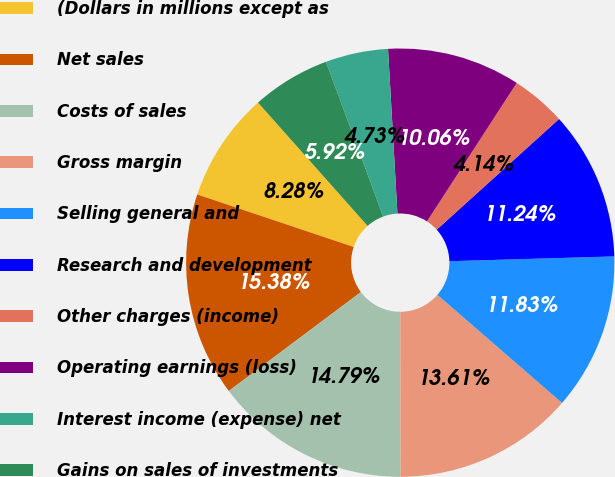Convert chart to OTSL. <chart><loc_0><loc_0><loc_500><loc_500><pie_chart><fcel>(Dollars in millions except as<fcel>Net sales<fcel>Costs of sales<fcel>Gross margin<fcel>Selling general and<fcel>Research and development<fcel>Other charges (income)<fcel>Operating earnings (loss)<fcel>Interest income (expense) net<fcel>Gains on sales of investments<nl><fcel>8.28%<fcel>15.38%<fcel>14.79%<fcel>13.61%<fcel>11.83%<fcel>11.24%<fcel>4.14%<fcel>10.06%<fcel>4.73%<fcel>5.92%<nl></chart> 